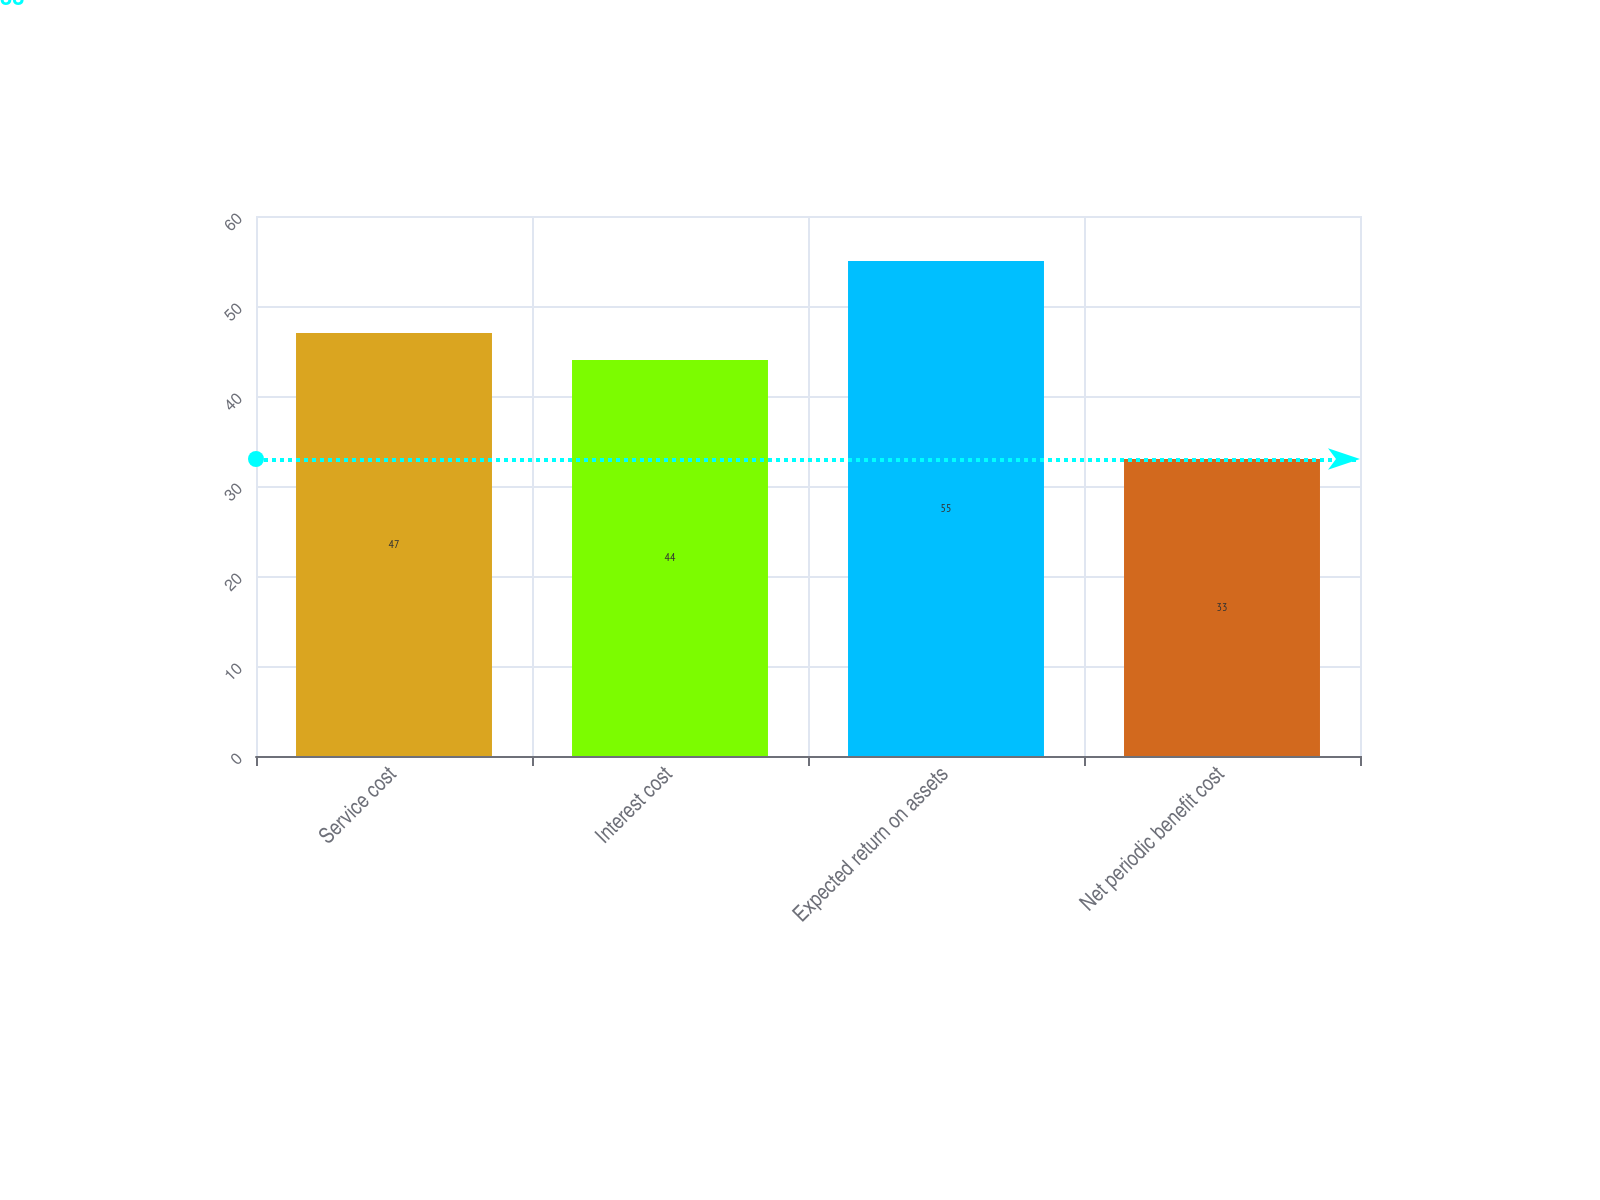Convert chart to OTSL. <chart><loc_0><loc_0><loc_500><loc_500><bar_chart><fcel>Service cost<fcel>Interest cost<fcel>Expected return on assets<fcel>Net periodic benefit cost<nl><fcel>47<fcel>44<fcel>55<fcel>33<nl></chart> 